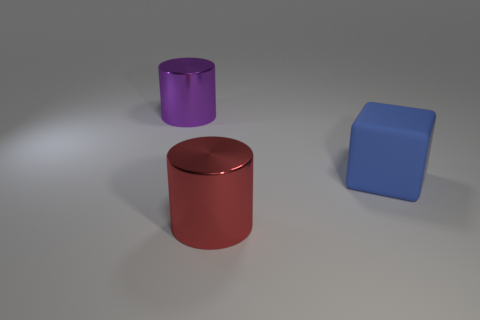What number of blocks are the same size as the purple object?
Your answer should be compact. 1. What number of purple objects are either metallic objects or large rubber things?
Give a very brief answer. 1. What shape is the metal object that is right of the metal cylinder that is behind the red metal object?
Keep it short and to the point. Cylinder. There is a blue matte object that is the same size as the purple shiny cylinder; what is its shape?
Offer a very short reply. Cube. Is the number of cylinders to the right of the large matte cube the same as the number of big blue things that are on the right side of the purple shiny thing?
Keep it short and to the point. No. There is a large red object; does it have the same shape as the metal object that is behind the blue cube?
Offer a very short reply. Yes. What number of other things are the same material as the big red thing?
Your response must be concise. 1. Are there any large purple metallic cylinders right of the matte object?
Your answer should be very brief. No. There is a purple metallic object; is its size the same as the object right of the red cylinder?
Ensure brevity in your answer.  Yes. There is a metal object that is to the left of the big cylinder that is in front of the blue cube; what color is it?
Give a very brief answer. Purple. 